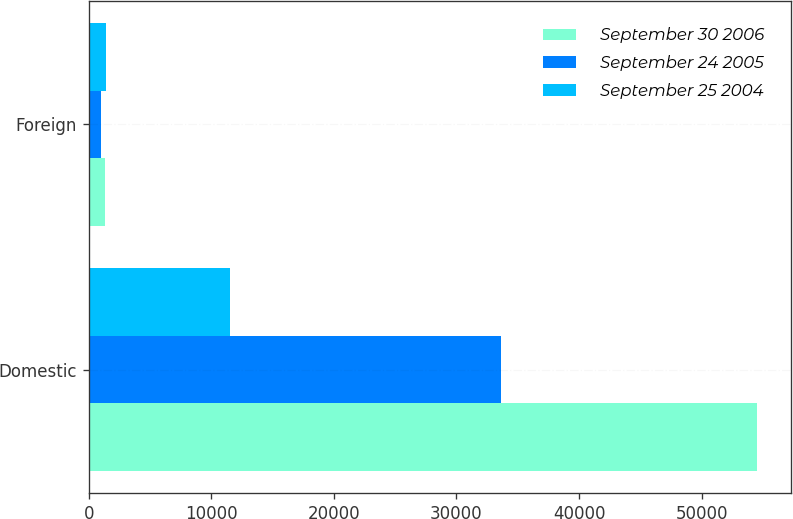Convert chart. <chart><loc_0><loc_0><loc_500><loc_500><stacked_bar_chart><ecel><fcel>Domestic<fcel>Foreign<nl><fcel>September 30 2006<fcel>54542<fcel>1319<nl><fcel>September 24 2005<fcel>33662<fcel>1033<nl><fcel>September 25 2004<fcel>11489<fcel>1438<nl></chart> 